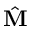<formula> <loc_0><loc_0><loc_500><loc_500>\hat { M }</formula> 